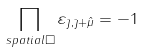Convert formula to latex. <formula><loc_0><loc_0><loc_500><loc_500>\prod _ { s p a t i a l \Box } \varepsilon _ { \bar { \jmath } , \bar { \jmath } + \hat { \mu } } = - 1</formula> 